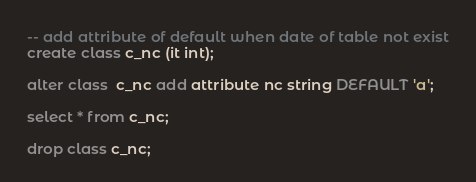Convert code to text. <code><loc_0><loc_0><loc_500><loc_500><_SQL_>-- add attribute of default when date of table not exist
create class c_nc (it int);

alter class  c_nc add attribute nc string DEFAULT 'a';

select * from c_nc;

drop class c_nc;</code> 